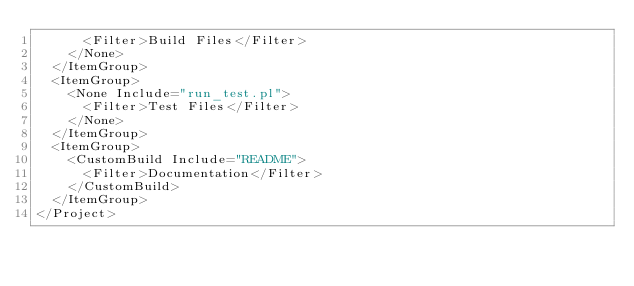<code> <loc_0><loc_0><loc_500><loc_500><_XML_>      <Filter>Build Files</Filter>
    </None>
  </ItemGroup>
  <ItemGroup>
    <None Include="run_test.pl">
      <Filter>Test Files</Filter>
    </None>
  </ItemGroup>
  <ItemGroup>
    <CustomBuild Include="README">
      <Filter>Documentation</Filter>
    </CustomBuild>
  </ItemGroup>
</Project>
</code> 